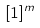Convert formula to latex. <formula><loc_0><loc_0><loc_500><loc_500>[ 1 ] ^ { m }</formula> 